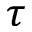Convert formula to latex. <formula><loc_0><loc_0><loc_500><loc_500>\tau</formula> 